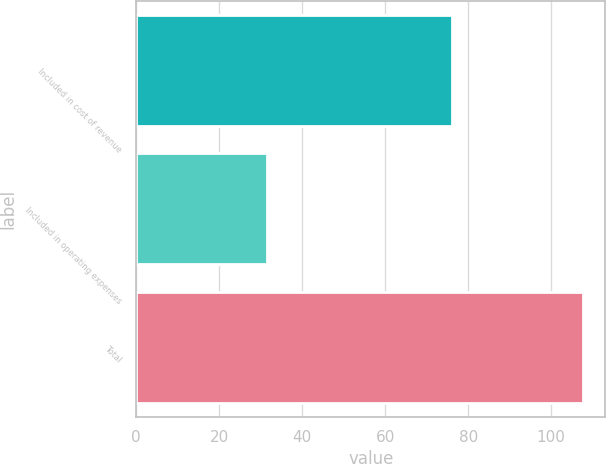Convert chart. <chart><loc_0><loc_0><loc_500><loc_500><bar_chart><fcel>Included in cost of revenue<fcel>Included in operating expenses<fcel>Total<nl><fcel>76.1<fcel>31.6<fcel>107.7<nl></chart> 